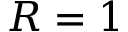Convert formula to latex. <formula><loc_0><loc_0><loc_500><loc_500>R = 1</formula> 